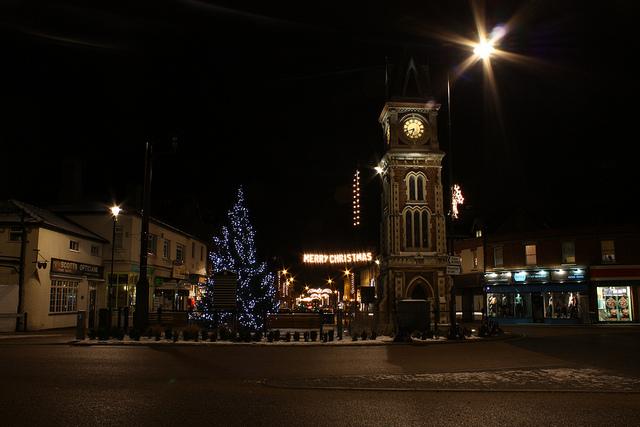What color is the clock tower?
Concise answer only. Brown. What color are the lights on the Christmas tree?
Answer briefly. Blue. How tall is the building in the background on the left?
Quick response, please. 2 stories. Is there water in the photo?
Concise answer only. No. Who would children be expecting this time of year?
Answer briefly. Santa. In the foreground are the lights shining up or down?
Be succinct. Down. Are there many cars seen?
Concise answer only. No. Is it a warm evening?
Keep it brief. No. Is this Vegas?
Quick response, please. No. Is there a photographers mark on the photo?
Write a very short answer. No. Would you take a walk alone in the night over here?
Concise answer only. Yes. What is the name of the building?
Be succinct. Clock tower. What time is it?
Short answer required. 9:35. What is the meaning of the white traffic sign?
Concise answer only. Light. Is this a small rural town scene?
Write a very short answer. Yes. What is that in the middle of the road?
Short answer required. Christmas tree. What is the large circular object?
Be succinct. Clock. Who died for the sins of the townspeople?
Answer briefly. Jesus. What are the blue lights on?
Keep it brief. Tree. 